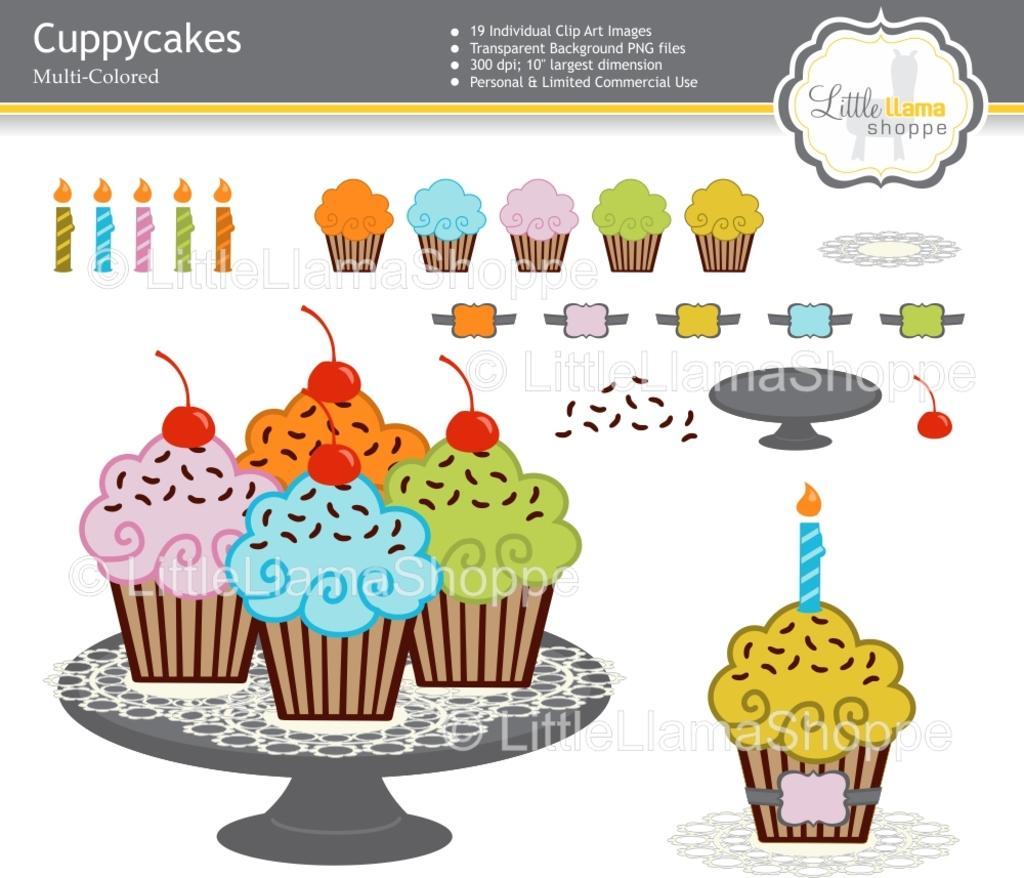Describe this image in one or two sentences. In this picture we can see a poster, here we can see cupcakes, candles, some objects and some text on it. 